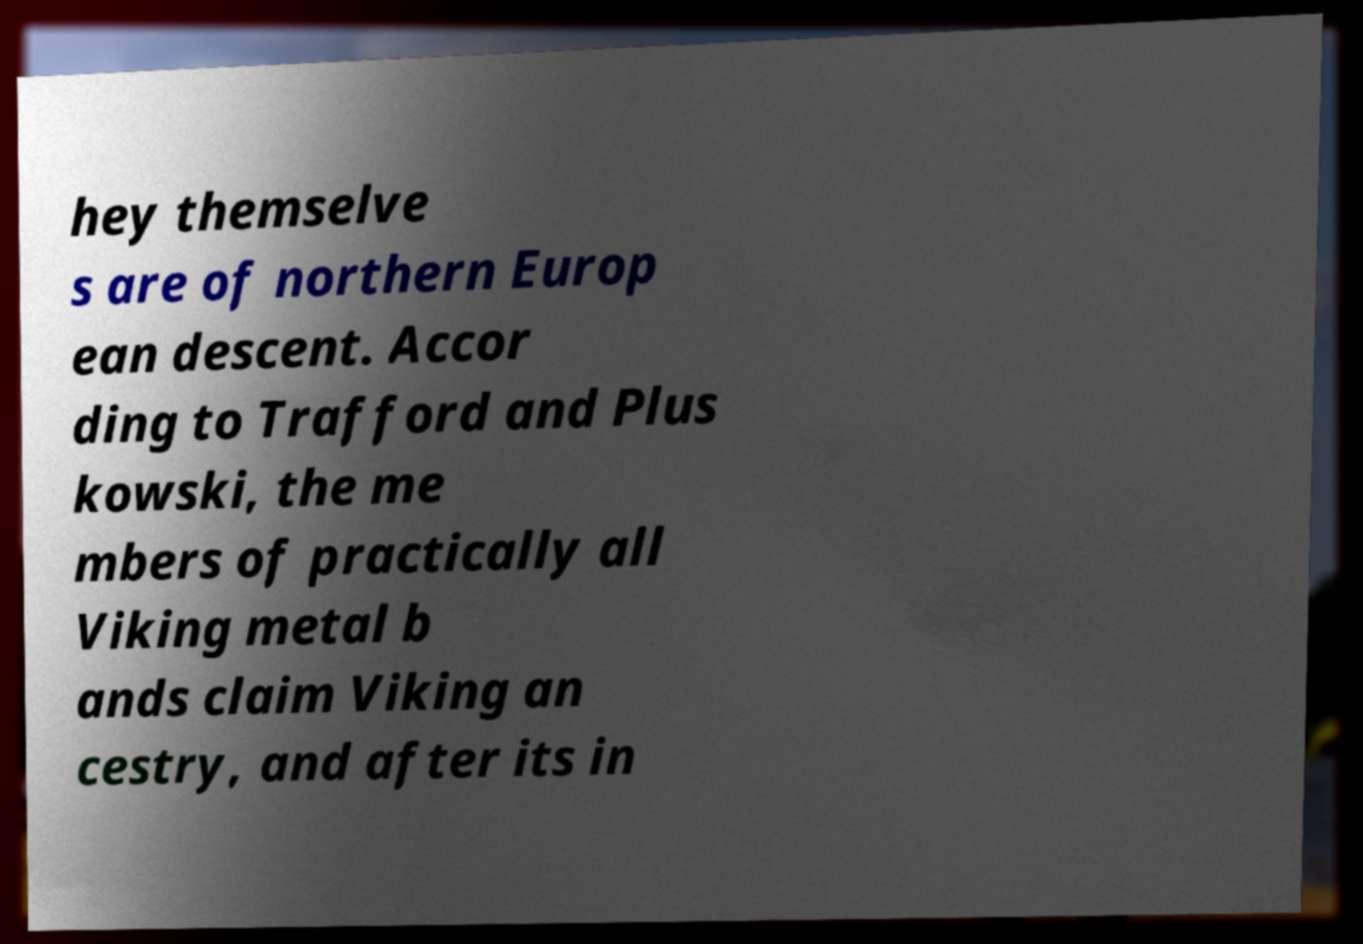For documentation purposes, I need the text within this image transcribed. Could you provide that? hey themselve s are of northern Europ ean descent. Accor ding to Trafford and Plus kowski, the me mbers of practically all Viking metal b ands claim Viking an cestry, and after its in 